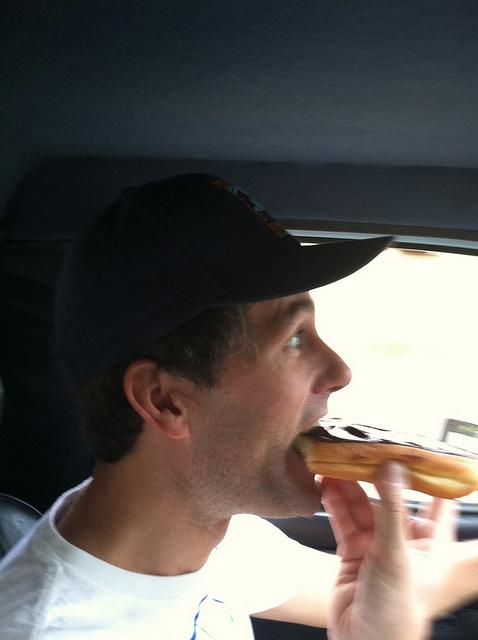What is the guy touching with his left hand?
Keep it brief. Steering wheel. Is this food sweet?
Give a very brief answer. Yes. Is the person wearing a ball cap?
Be succinct. Yes. What is this person eating?
Write a very short answer. Donut. 